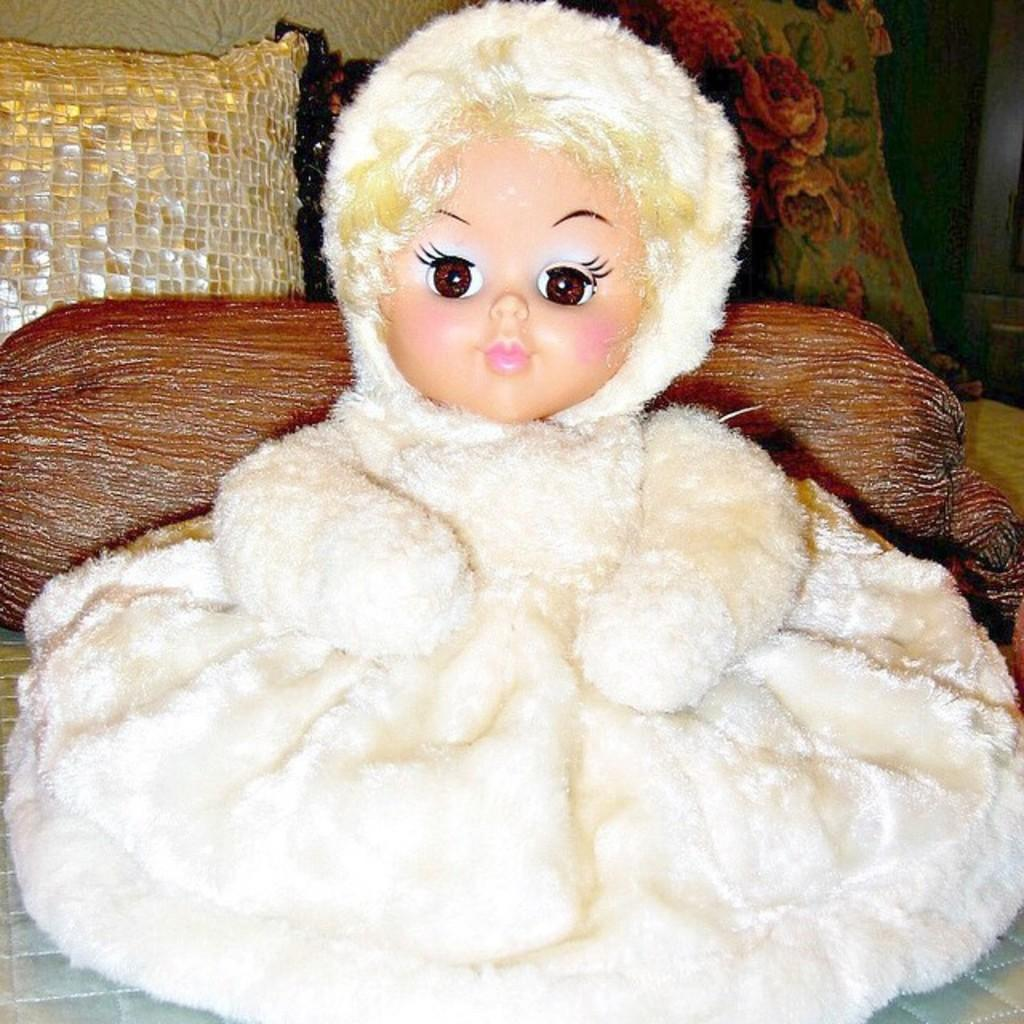What is the main subject of the image? There is a doll in the image. What can be seen in the background of the image? There are cushions and a pillow in the background of the image. What type of furniture is at the bottom of the image? There is a bed at the bottom of the image. Where is the gun hidden in the image? There is no gun present in the image. What type of wilderness can be seen through the window in the image? There is no window or wilderness visible in the image. 